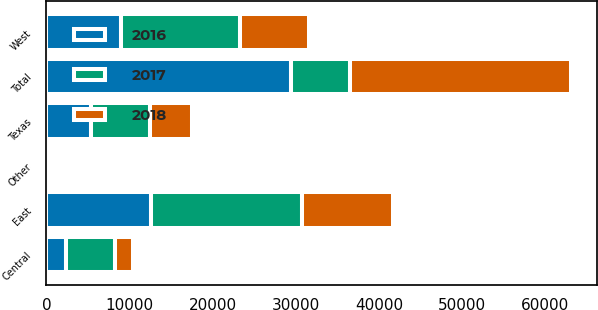Convert chart to OTSL. <chart><loc_0><loc_0><loc_500><loc_500><stacked_bar_chart><ecel><fcel>East<fcel>Central<fcel>Texas<fcel>West<fcel>Other<fcel>Total<nl><fcel>2017<fcel>18161<fcel>5865<fcel>7146<fcel>14352<fcel>103<fcel>7146<nl><fcel>2016<fcel>12625<fcel>2334<fcel>5341<fcel>8971<fcel>123<fcel>29394<nl><fcel>2018<fcel>10913<fcel>2266<fcel>5010<fcel>8241<fcel>133<fcel>26563<nl></chart> 